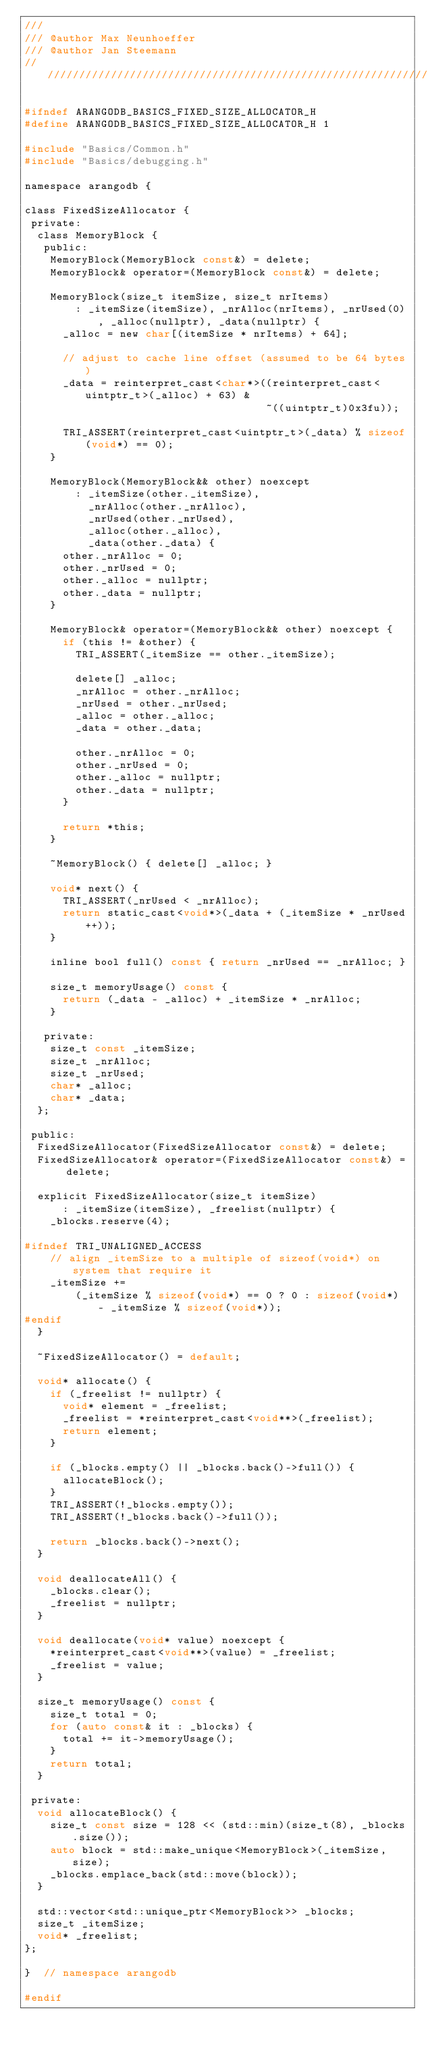<code> <loc_0><loc_0><loc_500><loc_500><_C_>///
/// @author Max Neunhoeffer
/// @author Jan Steemann
////////////////////////////////////////////////////////////////////////////////

#ifndef ARANGODB_BASICS_FIXED_SIZE_ALLOCATOR_H
#define ARANGODB_BASICS_FIXED_SIZE_ALLOCATOR_H 1

#include "Basics/Common.h"
#include "Basics/debugging.h"

namespace arangodb {

class FixedSizeAllocator {
 private:
  class MemoryBlock {
   public:
    MemoryBlock(MemoryBlock const&) = delete;
    MemoryBlock& operator=(MemoryBlock const&) = delete;

    MemoryBlock(size_t itemSize, size_t nrItems)
        : _itemSize(itemSize), _nrAlloc(nrItems), _nrUsed(0), _alloc(nullptr), _data(nullptr) {
      _alloc = new char[(itemSize * nrItems) + 64];

      // adjust to cache line offset (assumed to be 64 bytes)
      _data = reinterpret_cast<char*>((reinterpret_cast<uintptr_t>(_alloc) + 63) &
                                      ~((uintptr_t)0x3fu));

      TRI_ASSERT(reinterpret_cast<uintptr_t>(_data) % sizeof(void*) == 0);
    }

    MemoryBlock(MemoryBlock&& other) noexcept
        : _itemSize(other._itemSize),
          _nrAlloc(other._nrAlloc),
          _nrUsed(other._nrUsed),
          _alloc(other._alloc),
          _data(other._data) {
      other._nrAlloc = 0;
      other._nrUsed = 0;
      other._alloc = nullptr;
      other._data = nullptr;
    }

    MemoryBlock& operator=(MemoryBlock&& other) noexcept {
      if (this != &other) {
        TRI_ASSERT(_itemSize == other._itemSize);

        delete[] _alloc;
        _nrAlloc = other._nrAlloc;
        _nrUsed = other._nrUsed;
        _alloc = other._alloc;
        _data = other._data;

        other._nrAlloc = 0;
        other._nrUsed = 0;
        other._alloc = nullptr;
        other._data = nullptr;
      }

      return *this;
    }

    ~MemoryBlock() { delete[] _alloc; }

    void* next() {
      TRI_ASSERT(_nrUsed < _nrAlloc);
      return static_cast<void*>(_data + (_itemSize * _nrUsed++));
    }

    inline bool full() const { return _nrUsed == _nrAlloc; }

    size_t memoryUsage() const {
      return (_data - _alloc) + _itemSize * _nrAlloc;
    }

   private:
    size_t const _itemSize;
    size_t _nrAlloc;
    size_t _nrUsed;
    char* _alloc;
    char* _data;
  };

 public:
  FixedSizeAllocator(FixedSizeAllocator const&) = delete;
  FixedSizeAllocator& operator=(FixedSizeAllocator const&) = delete;

  explicit FixedSizeAllocator(size_t itemSize)
      : _itemSize(itemSize), _freelist(nullptr) {
    _blocks.reserve(4);

#ifndef TRI_UNALIGNED_ACCESS
    // align _itemSize to a multiple of sizeof(void*) on system that require it
    _itemSize +=
        (_itemSize % sizeof(void*) == 0 ? 0 : sizeof(void*) - _itemSize % sizeof(void*));
#endif
  }

  ~FixedSizeAllocator() = default;

  void* allocate() {
    if (_freelist != nullptr) {
      void* element = _freelist;
      _freelist = *reinterpret_cast<void**>(_freelist);
      return element;
    }

    if (_blocks.empty() || _blocks.back()->full()) {
      allocateBlock();
    }
    TRI_ASSERT(!_blocks.empty());
    TRI_ASSERT(!_blocks.back()->full());

    return _blocks.back()->next();
  }

  void deallocateAll() {
    _blocks.clear();
    _freelist = nullptr;
  }

  void deallocate(void* value) noexcept {
    *reinterpret_cast<void**>(value) = _freelist;
    _freelist = value;
  }

  size_t memoryUsage() const {
    size_t total = 0;
    for (auto const& it : _blocks) {
      total += it->memoryUsage();
    }
    return total;
  }

 private:
  void allocateBlock() {
    size_t const size = 128 << (std::min)(size_t(8), _blocks.size());
    auto block = std::make_unique<MemoryBlock>(_itemSize, size);
    _blocks.emplace_back(std::move(block));
  }

  std::vector<std::unique_ptr<MemoryBlock>> _blocks;
  size_t _itemSize;
  void* _freelist;
};

}  // namespace arangodb

#endif
</code> 